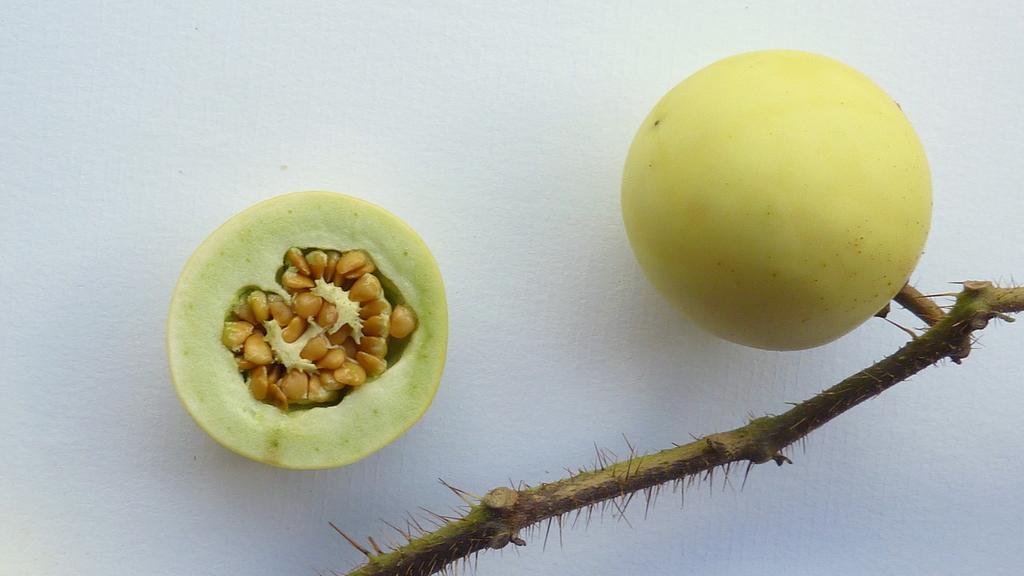How would you summarize this image in a sentence or two? In this image in the center there is one fruit, and on the left side there is another fruit which is half sliced. And at the bottom there is a stem and there is a white background. 